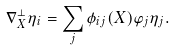<formula> <loc_0><loc_0><loc_500><loc_500>\nabla _ { X } ^ { \perp } \eta _ { i } = \sum _ { j } \phi _ { i j } ( X ) \varphi _ { j } \eta _ { j } .</formula> 